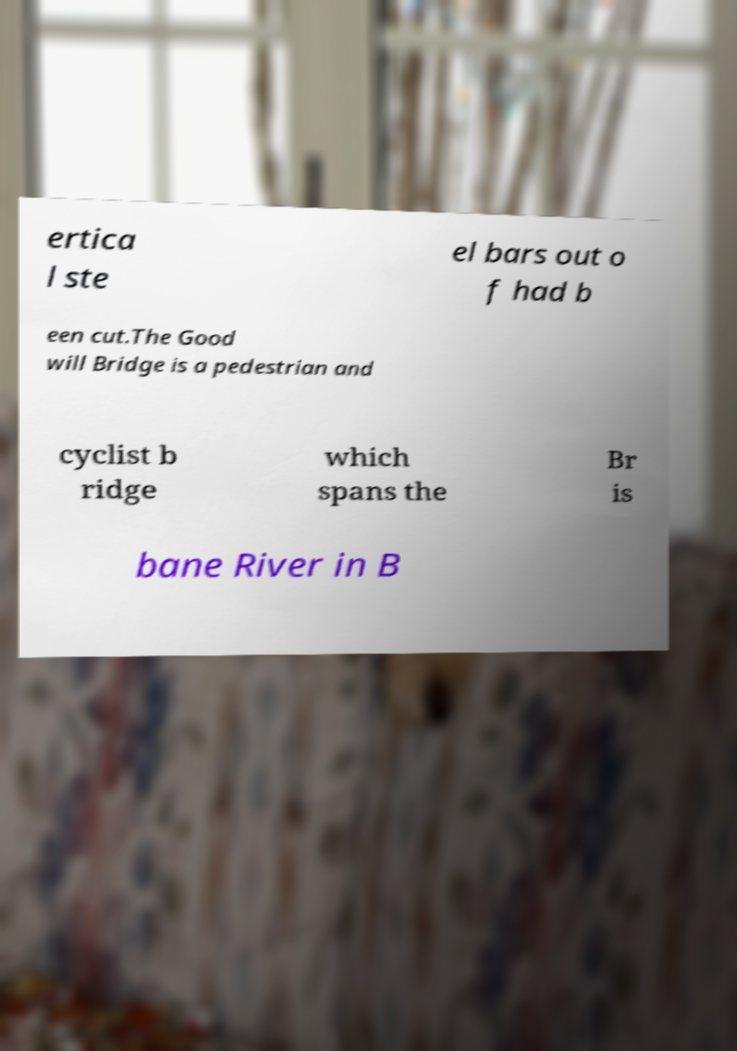Please read and relay the text visible in this image. What does it say? ertica l ste el bars out o f had b een cut.The Good will Bridge is a pedestrian and cyclist b ridge which spans the Br is bane River in B 